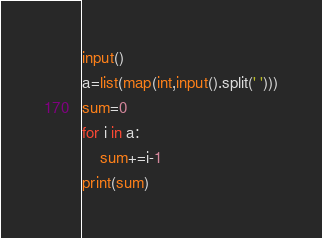Convert code to text. <code><loc_0><loc_0><loc_500><loc_500><_Python_>input()
a=list(map(int,input().split(' ')))
sum=0
for i in a:
    sum+=i-1
print(sum)
</code> 